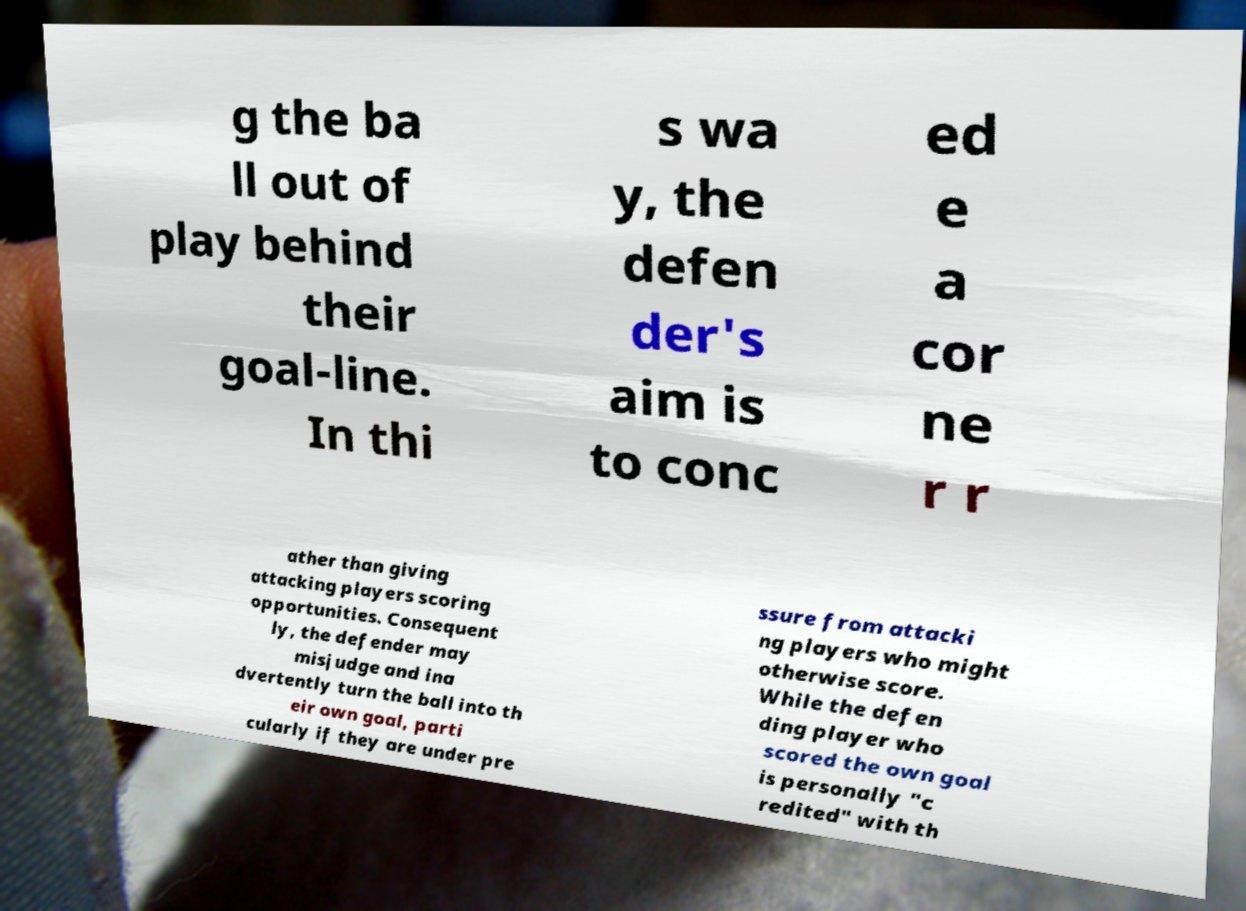There's text embedded in this image that I need extracted. Can you transcribe it verbatim? g the ba ll out of play behind their goal-line. In thi s wa y, the defen der's aim is to conc ed e a cor ne r r ather than giving attacking players scoring opportunities. Consequent ly, the defender may misjudge and ina dvertently turn the ball into th eir own goal, parti cularly if they are under pre ssure from attacki ng players who might otherwise score. While the defen ding player who scored the own goal is personally "c redited" with th 